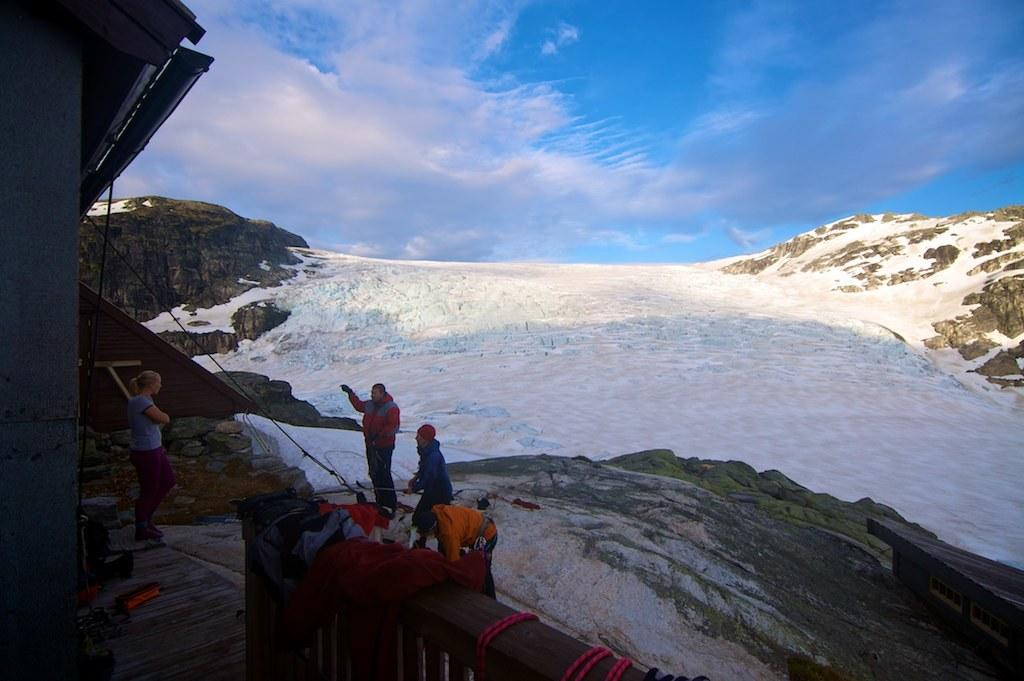How many people are in the image? There are four persons in the image. What else can be seen in the image besides the people? There is a rock, clothes, and snow in the image. What is the background of the image? The sky is visible in the background of the image, and there are clouds in the sky. What type of linen is being used to wrap the bottle in the image? There is no bottle or linen present in the image. How does the wax interact with the snow in the image? There is no wax present in the image, so it cannot interact with the snow. 